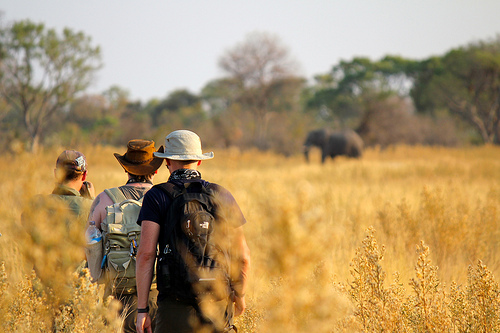Is the grass dried or wet? The grass is dried. 